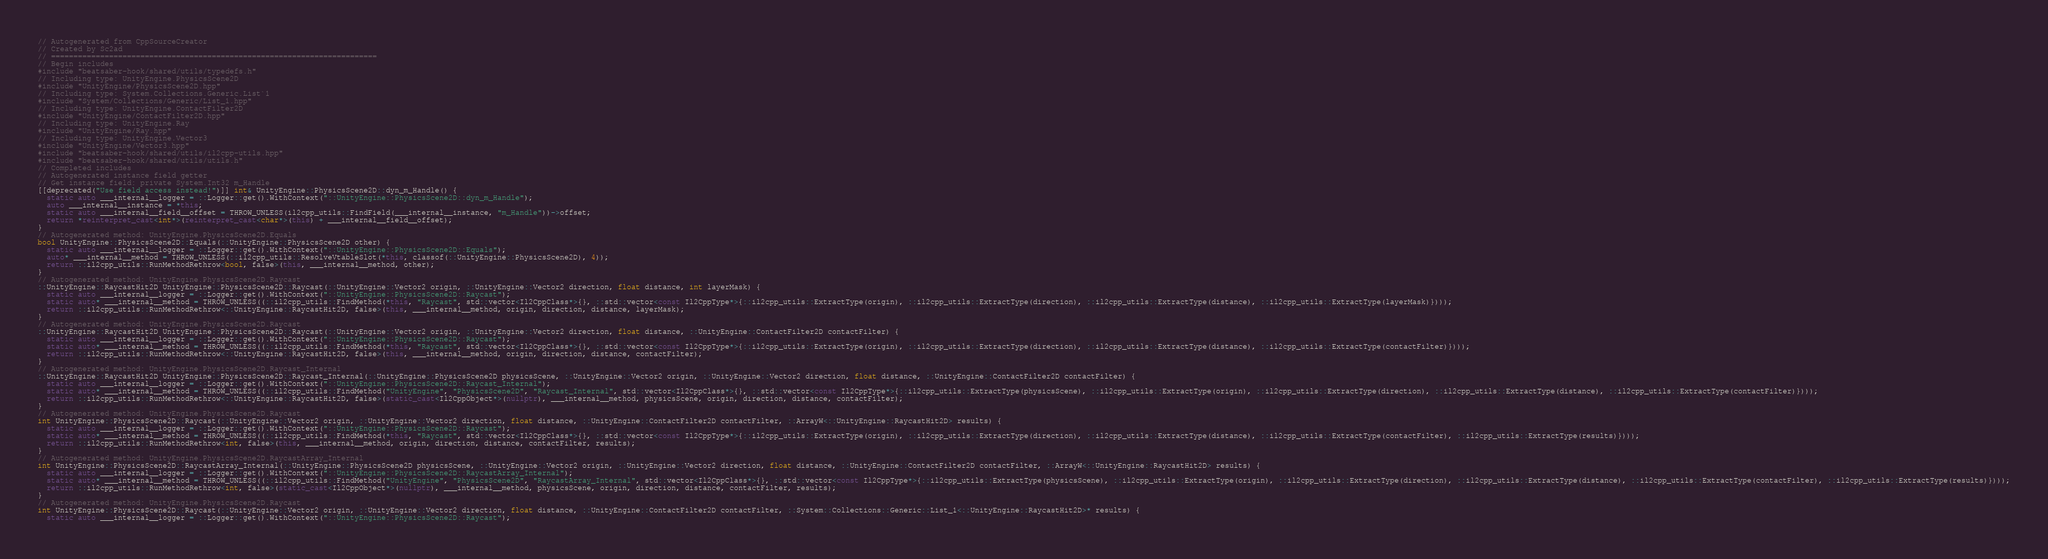Convert code to text. <code><loc_0><loc_0><loc_500><loc_500><_C++_>// Autogenerated from CppSourceCreator
// Created by Sc2ad
// =========================================================================
// Begin includes
#include "beatsaber-hook/shared/utils/typedefs.h"
// Including type: UnityEngine.PhysicsScene2D
#include "UnityEngine/PhysicsScene2D.hpp"
// Including type: System.Collections.Generic.List`1
#include "System/Collections/Generic/List_1.hpp"
// Including type: UnityEngine.ContactFilter2D
#include "UnityEngine/ContactFilter2D.hpp"
// Including type: UnityEngine.Ray
#include "UnityEngine/Ray.hpp"
// Including type: UnityEngine.Vector3
#include "UnityEngine/Vector3.hpp"
#include "beatsaber-hook/shared/utils/il2cpp-utils.hpp"
#include "beatsaber-hook/shared/utils/utils.h"
// Completed includes
// Autogenerated instance field getter
// Get instance field: private System.Int32 m_Handle
[[deprecated("Use field access instead!")]] int& UnityEngine::PhysicsScene2D::dyn_m_Handle() {
  static auto ___internal__logger = ::Logger::get().WithContext("::UnityEngine::PhysicsScene2D::dyn_m_Handle");
  auto ___internal__instance = *this;
  static auto ___internal__field__offset = THROW_UNLESS(il2cpp_utils::FindField(___internal__instance, "m_Handle"))->offset;
  return *reinterpret_cast<int*>(reinterpret_cast<char*>(this) + ___internal__field__offset);
}
// Autogenerated method: UnityEngine.PhysicsScene2D.Equals
bool UnityEngine::PhysicsScene2D::Equals(::UnityEngine::PhysicsScene2D other) {
  static auto ___internal__logger = ::Logger::get().WithContext("::UnityEngine::PhysicsScene2D::Equals");
  auto* ___internal__method = THROW_UNLESS(::il2cpp_utils::ResolveVtableSlot(*this, classof(::UnityEngine::PhysicsScene2D), 4));
  return ::il2cpp_utils::RunMethodRethrow<bool, false>(this, ___internal__method, other);
}
// Autogenerated method: UnityEngine.PhysicsScene2D.Raycast
::UnityEngine::RaycastHit2D UnityEngine::PhysicsScene2D::Raycast(::UnityEngine::Vector2 origin, ::UnityEngine::Vector2 direction, float distance, int layerMask) {
  static auto ___internal__logger = ::Logger::get().WithContext("::UnityEngine::PhysicsScene2D::Raycast");
  static auto* ___internal__method = THROW_UNLESS((::il2cpp_utils::FindMethod(*this, "Raycast", std::vector<Il2CppClass*>{}, ::std::vector<const Il2CppType*>{::il2cpp_utils::ExtractType(origin), ::il2cpp_utils::ExtractType(direction), ::il2cpp_utils::ExtractType(distance), ::il2cpp_utils::ExtractType(layerMask)})));
  return ::il2cpp_utils::RunMethodRethrow<::UnityEngine::RaycastHit2D, false>(this, ___internal__method, origin, direction, distance, layerMask);
}
// Autogenerated method: UnityEngine.PhysicsScene2D.Raycast
::UnityEngine::RaycastHit2D UnityEngine::PhysicsScene2D::Raycast(::UnityEngine::Vector2 origin, ::UnityEngine::Vector2 direction, float distance, ::UnityEngine::ContactFilter2D contactFilter) {
  static auto ___internal__logger = ::Logger::get().WithContext("::UnityEngine::PhysicsScene2D::Raycast");
  static auto* ___internal__method = THROW_UNLESS((::il2cpp_utils::FindMethod(*this, "Raycast", std::vector<Il2CppClass*>{}, ::std::vector<const Il2CppType*>{::il2cpp_utils::ExtractType(origin), ::il2cpp_utils::ExtractType(direction), ::il2cpp_utils::ExtractType(distance), ::il2cpp_utils::ExtractType(contactFilter)})));
  return ::il2cpp_utils::RunMethodRethrow<::UnityEngine::RaycastHit2D, false>(this, ___internal__method, origin, direction, distance, contactFilter);
}
// Autogenerated method: UnityEngine.PhysicsScene2D.Raycast_Internal
::UnityEngine::RaycastHit2D UnityEngine::PhysicsScene2D::Raycast_Internal(::UnityEngine::PhysicsScene2D physicsScene, ::UnityEngine::Vector2 origin, ::UnityEngine::Vector2 direction, float distance, ::UnityEngine::ContactFilter2D contactFilter) {
  static auto ___internal__logger = ::Logger::get().WithContext("::UnityEngine::PhysicsScene2D::Raycast_Internal");
  static auto* ___internal__method = THROW_UNLESS((::il2cpp_utils::FindMethod("UnityEngine", "PhysicsScene2D", "Raycast_Internal", std::vector<Il2CppClass*>{}, ::std::vector<const Il2CppType*>{::il2cpp_utils::ExtractType(physicsScene), ::il2cpp_utils::ExtractType(origin), ::il2cpp_utils::ExtractType(direction), ::il2cpp_utils::ExtractType(distance), ::il2cpp_utils::ExtractType(contactFilter)})));
  return ::il2cpp_utils::RunMethodRethrow<::UnityEngine::RaycastHit2D, false>(static_cast<Il2CppObject*>(nullptr), ___internal__method, physicsScene, origin, direction, distance, contactFilter);
}
// Autogenerated method: UnityEngine.PhysicsScene2D.Raycast
int UnityEngine::PhysicsScene2D::Raycast(::UnityEngine::Vector2 origin, ::UnityEngine::Vector2 direction, float distance, ::UnityEngine::ContactFilter2D contactFilter, ::ArrayW<::UnityEngine::RaycastHit2D> results) {
  static auto ___internal__logger = ::Logger::get().WithContext("::UnityEngine::PhysicsScene2D::Raycast");
  static auto* ___internal__method = THROW_UNLESS((::il2cpp_utils::FindMethod(*this, "Raycast", std::vector<Il2CppClass*>{}, ::std::vector<const Il2CppType*>{::il2cpp_utils::ExtractType(origin), ::il2cpp_utils::ExtractType(direction), ::il2cpp_utils::ExtractType(distance), ::il2cpp_utils::ExtractType(contactFilter), ::il2cpp_utils::ExtractType(results)})));
  return ::il2cpp_utils::RunMethodRethrow<int, false>(this, ___internal__method, origin, direction, distance, contactFilter, results);
}
// Autogenerated method: UnityEngine.PhysicsScene2D.RaycastArray_Internal
int UnityEngine::PhysicsScene2D::RaycastArray_Internal(::UnityEngine::PhysicsScene2D physicsScene, ::UnityEngine::Vector2 origin, ::UnityEngine::Vector2 direction, float distance, ::UnityEngine::ContactFilter2D contactFilter, ::ArrayW<::UnityEngine::RaycastHit2D> results) {
  static auto ___internal__logger = ::Logger::get().WithContext("::UnityEngine::PhysicsScene2D::RaycastArray_Internal");
  static auto* ___internal__method = THROW_UNLESS((::il2cpp_utils::FindMethod("UnityEngine", "PhysicsScene2D", "RaycastArray_Internal", std::vector<Il2CppClass*>{}, ::std::vector<const Il2CppType*>{::il2cpp_utils::ExtractType(physicsScene), ::il2cpp_utils::ExtractType(origin), ::il2cpp_utils::ExtractType(direction), ::il2cpp_utils::ExtractType(distance), ::il2cpp_utils::ExtractType(contactFilter), ::il2cpp_utils::ExtractType(results)})));
  return ::il2cpp_utils::RunMethodRethrow<int, false>(static_cast<Il2CppObject*>(nullptr), ___internal__method, physicsScene, origin, direction, distance, contactFilter, results);
}
// Autogenerated method: UnityEngine.PhysicsScene2D.Raycast
int UnityEngine::PhysicsScene2D::Raycast(::UnityEngine::Vector2 origin, ::UnityEngine::Vector2 direction, float distance, ::UnityEngine::ContactFilter2D contactFilter, ::System::Collections::Generic::List_1<::UnityEngine::RaycastHit2D>* results) {
  static auto ___internal__logger = ::Logger::get().WithContext("::UnityEngine::PhysicsScene2D::Raycast");</code> 